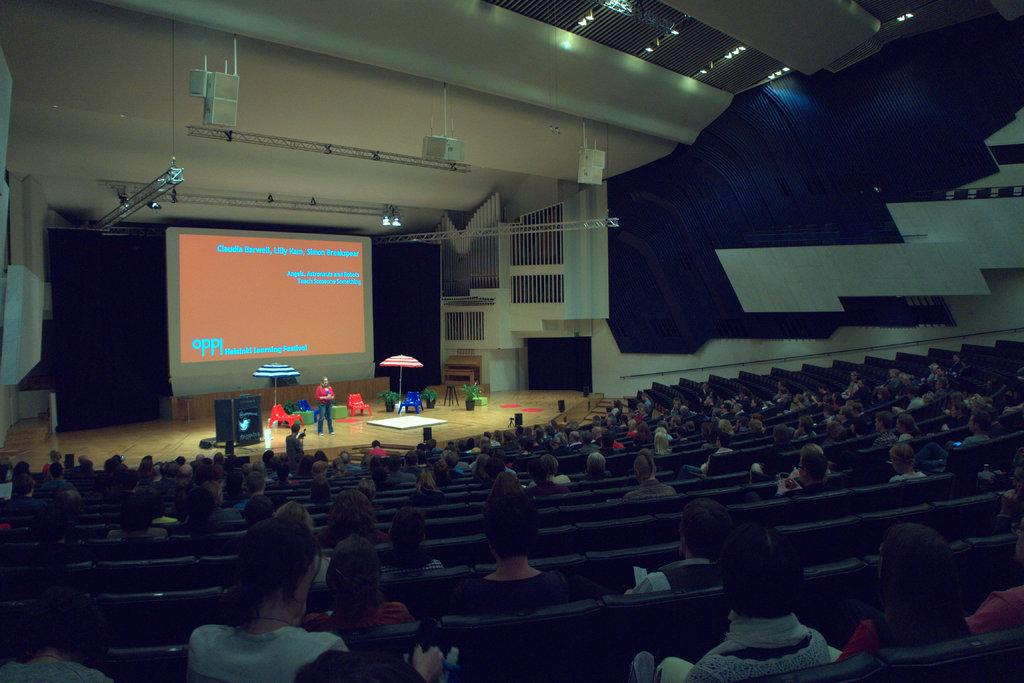<image>
Relay a brief, clear account of the picture shown. An auditorium with a presentation from the Helsinki learning festival. 